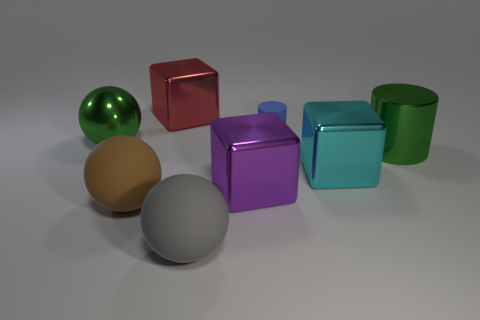Is there any other thing that has the same size as the blue cylinder?
Provide a succinct answer. No. Does the rubber object behind the large brown thing have the same size as the green thing on the left side of the gray matte object?
Keep it short and to the point. No. There is a large thing that is left of the red object and in front of the big cyan metallic thing; what material is it?
Your answer should be very brief. Rubber. Are there fewer large green cylinders than big green blocks?
Your answer should be very brief. No. There is a brown ball in front of the large green metal object left of the large cyan cube; how big is it?
Your response must be concise. Large. What is the shape of the green thing right of the metal cube that is behind the cylinder that is in front of the small blue cylinder?
Your response must be concise. Cylinder. The big sphere that is made of the same material as the cyan block is what color?
Your answer should be very brief. Green. There is a metal cube behind the matte thing to the right of the matte object that is in front of the large brown matte thing; what color is it?
Keep it short and to the point. Red. What number of balls are either cyan metal things or large purple metallic objects?
Make the answer very short. 0. What material is the large thing that is the same color as the shiny sphere?
Your answer should be compact. Metal. 